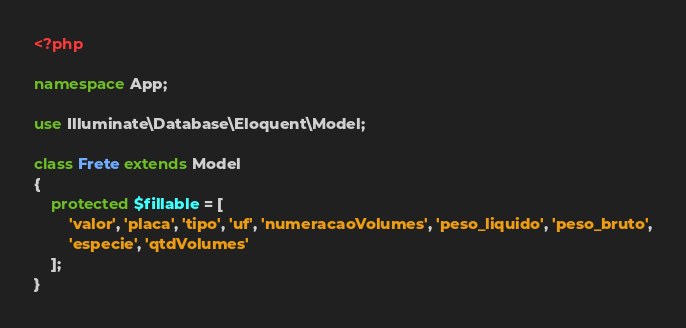<code> <loc_0><loc_0><loc_500><loc_500><_PHP_><?php

namespace App;

use Illuminate\Database\Eloquent\Model;

class Frete extends Model
{
    protected $fillable = [
        'valor', 'placa', 'tipo', 'uf', 'numeracaoVolumes', 'peso_liquido', 'peso_bruto',
        'especie', 'qtdVolumes'
    ];
}
</code> 